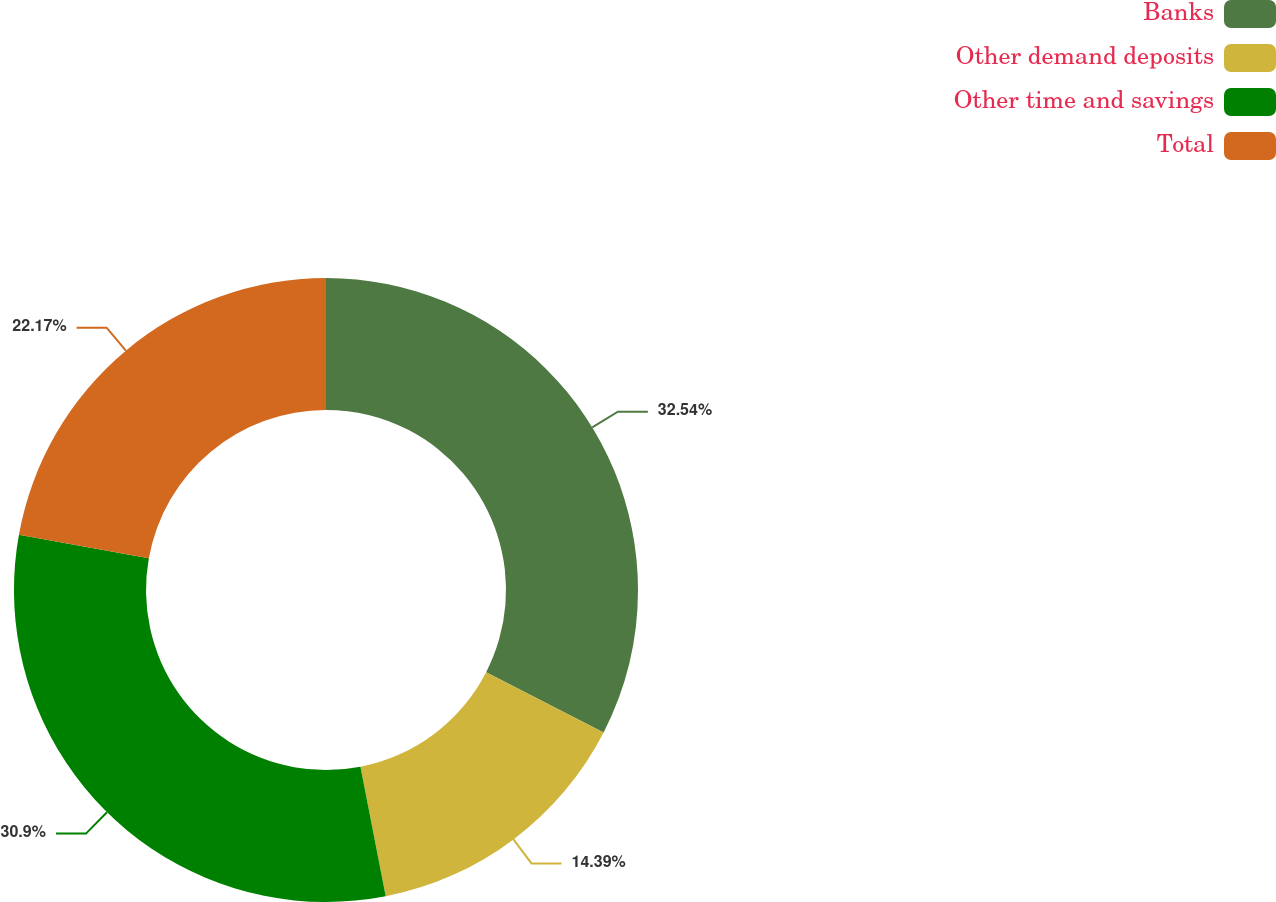Convert chart. <chart><loc_0><loc_0><loc_500><loc_500><pie_chart><fcel>Banks<fcel>Other demand deposits<fcel>Other time and savings<fcel>Total<nl><fcel>32.55%<fcel>14.39%<fcel>30.9%<fcel>22.17%<nl></chart> 